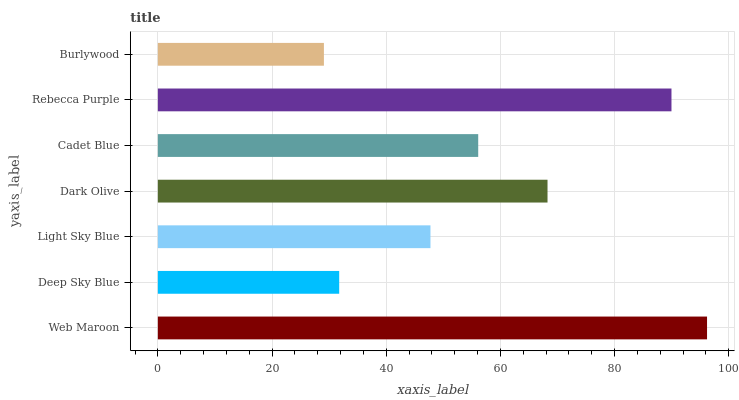Is Burlywood the minimum?
Answer yes or no. Yes. Is Web Maroon the maximum?
Answer yes or no. Yes. Is Deep Sky Blue the minimum?
Answer yes or no. No. Is Deep Sky Blue the maximum?
Answer yes or no. No. Is Web Maroon greater than Deep Sky Blue?
Answer yes or no. Yes. Is Deep Sky Blue less than Web Maroon?
Answer yes or no. Yes. Is Deep Sky Blue greater than Web Maroon?
Answer yes or no. No. Is Web Maroon less than Deep Sky Blue?
Answer yes or no. No. Is Cadet Blue the high median?
Answer yes or no. Yes. Is Cadet Blue the low median?
Answer yes or no. Yes. Is Light Sky Blue the high median?
Answer yes or no. No. Is Rebecca Purple the low median?
Answer yes or no. No. 